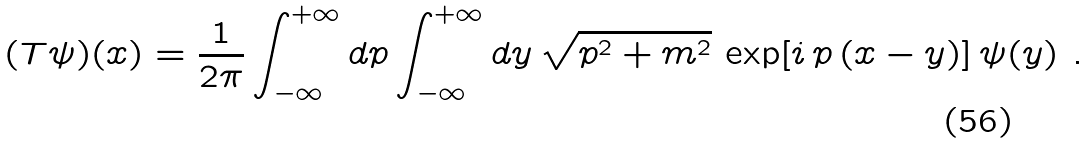<formula> <loc_0><loc_0><loc_500><loc_500>( T \psi ) ( x ) = \frac { 1 } { 2 \pi } \int _ { - \infty } ^ { + \infty } d p \int _ { - \infty } ^ { + \infty } d y \, \sqrt { p ^ { 2 } + m ^ { 2 } } \, \exp [ i \, p \, ( x - y ) ] \, \psi ( y ) \ .</formula> 